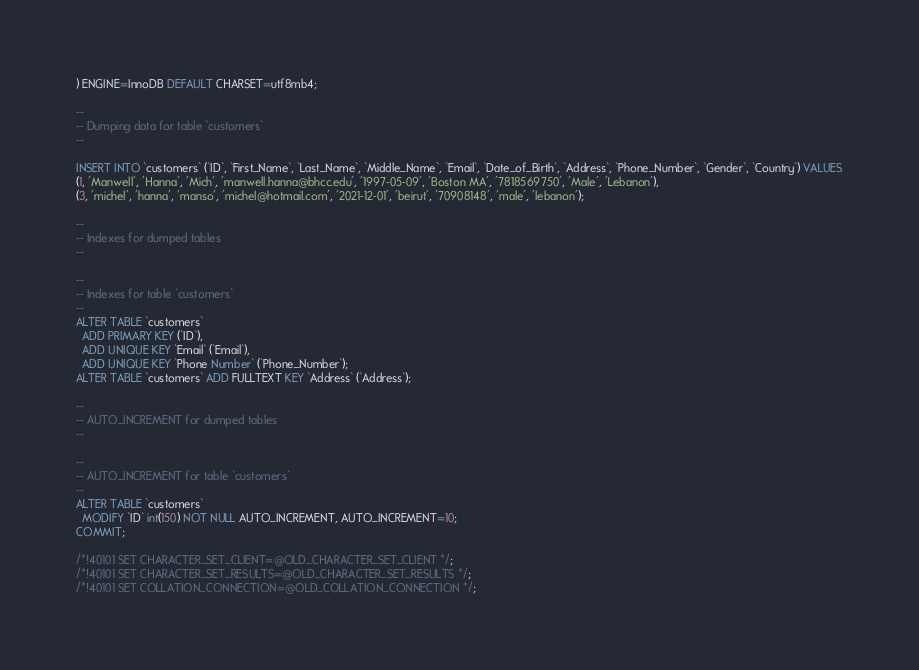<code> <loc_0><loc_0><loc_500><loc_500><_SQL_>) ENGINE=InnoDB DEFAULT CHARSET=utf8mb4;

--
-- Dumping data for table `customers`
--

INSERT INTO `customers` (`ID`, `First_Name`, `Last_Name`, `Middle_Name`, `Email`, `Date_of_Birth`, `Address`, `Phone_Number`, `Gender`, `Country`) VALUES
(1, 'Manwell', 'Hanna', 'Mich', 'manwell.hanna@bhcc.edu', '1997-05-09', 'Boston MA', '7818569750', 'Male', 'Lebanon'),
(3, 'michel', 'hanna', 'manso', 'michel@hotmail.com', '2021-12-01', 'beirut', '70908148', 'male', 'lebanon');

--
-- Indexes for dumped tables
--

--
-- Indexes for table `customers`
--
ALTER TABLE `customers`
  ADD PRIMARY KEY (`ID`),
  ADD UNIQUE KEY `Email` (`Email`),
  ADD UNIQUE KEY `Phone Number` (`Phone_Number`);
ALTER TABLE `customers` ADD FULLTEXT KEY `Address` (`Address`);

--
-- AUTO_INCREMENT for dumped tables
--

--
-- AUTO_INCREMENT for table `customers`
--
ALTER TABLE `customers`
  MODIFY `ID` int(150) NOT NULL AUTO_INCREMENT, AUTO_INCREMENT=10;
COMMIT;

/*!40101 SET CHARACTER_SET_CLIENT=@OLD_CHARACTER_SET_CLIENT */;
/*!40101 SET CHARACTER_SET_RESULTS=@OLD_CHARACTER_SET_RESULTS */;
/*!40101 SET COLLATION_CONNECTION=@OLD_COLLATION_CONNECTION */;
</code> 